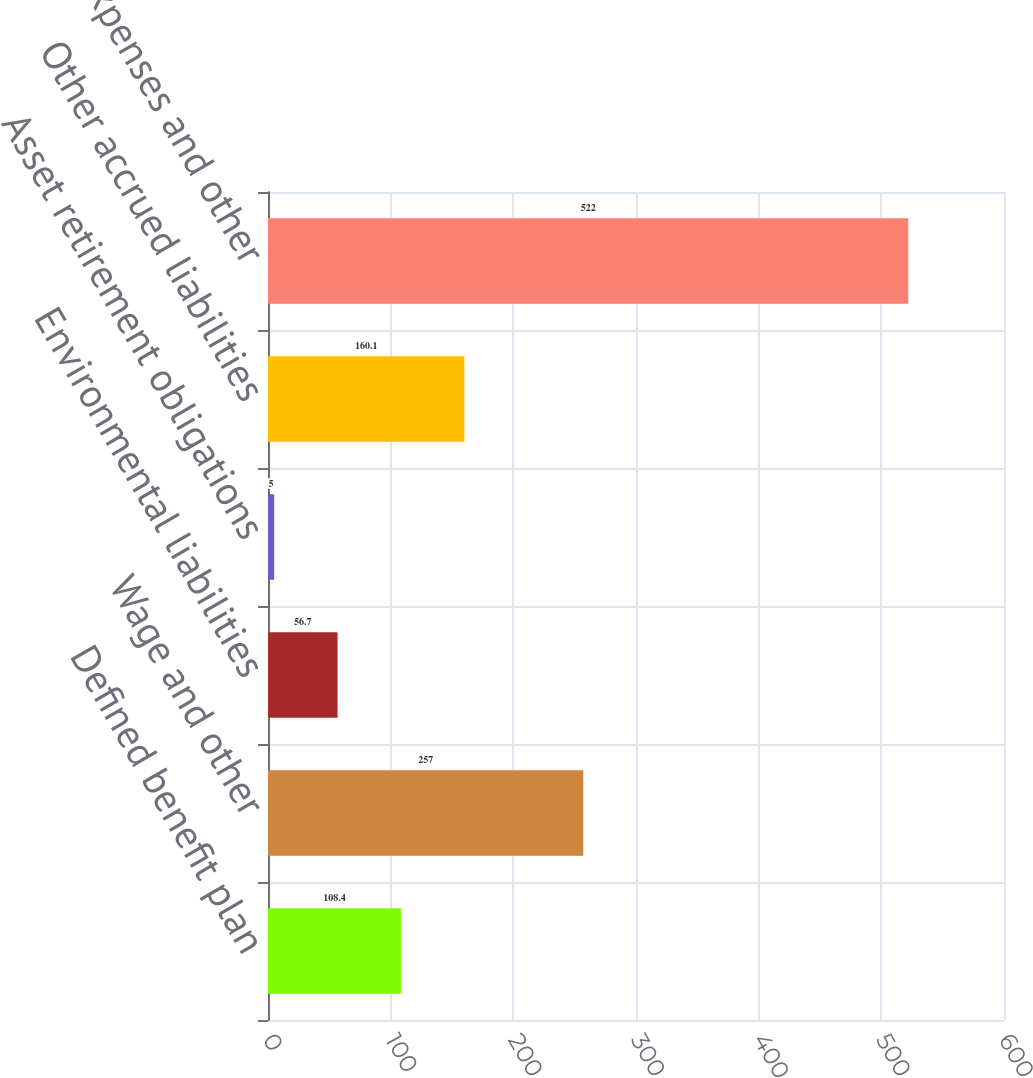Convert chart. <chart><loc_0><loc_0><loc_500><loc_500><bar_chart><fcel>Defined benefit plan<fcel>Wage and other<fcel>Environmental liabilities<fcel>Asset retirement obligations<fcel>Other accrued liabilities<fcel>Accrued expenses and other<nl><fcel>108.4<fcel>257<fcel>56.7<fcel>5<fcel>160.1<fcel>522<nl></chart> 